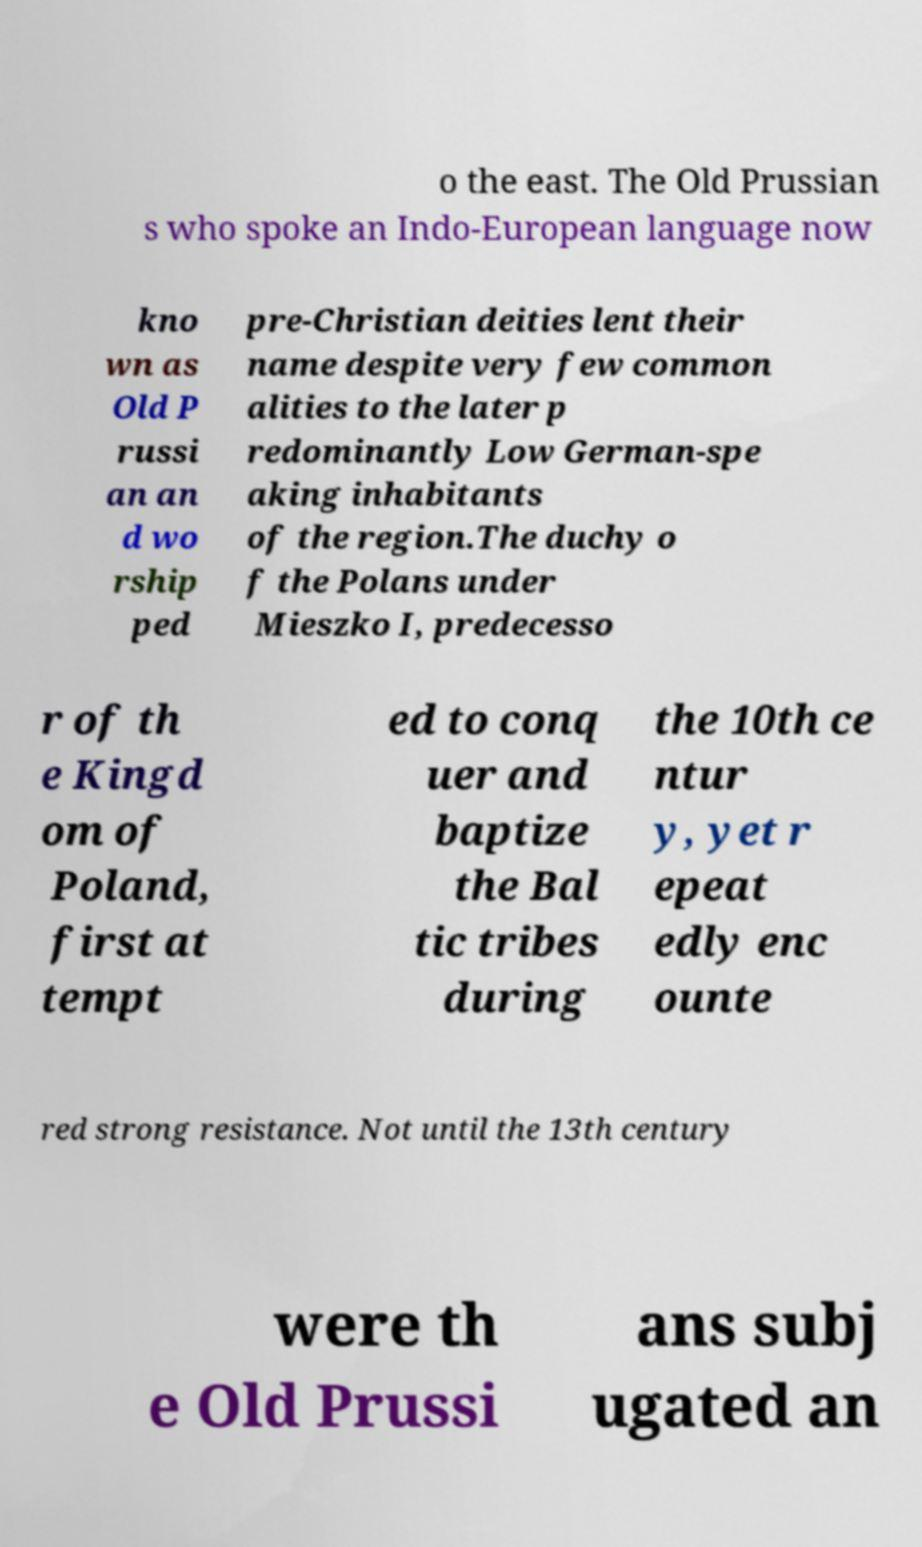There's text embedded in this image that I need extracted. Can you transcribe it verbatim? o the east. The Old Prussian s who spoke an Indo-European language now kno wn as Old P russi an an d wo rship ped pre-Christian deities lent their name despite very few common alities to the later p redominantly Low German-spe aking inhabitants of the region.The duchy o f the Polans under Mieszko I, predecesso r of th e Kingd om of Poland, first at tempt ed to conq uer and baptize the Bal tic tribes during the 10th ce ntur y, yet r epeat edly enc ounte red strong resistance. Not until the 13th century were th e Old Prussi ans subj ugated an 